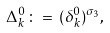Convert formula to latex. <formula><loc_0><loc_0><loc_500><loc_500>\Delta _ { k } ^ { 0 } \, \colon = \, ( \delta _ { k } ^ { 0 } ) ^ { \sigma _ { 3 } } ,</formula> 